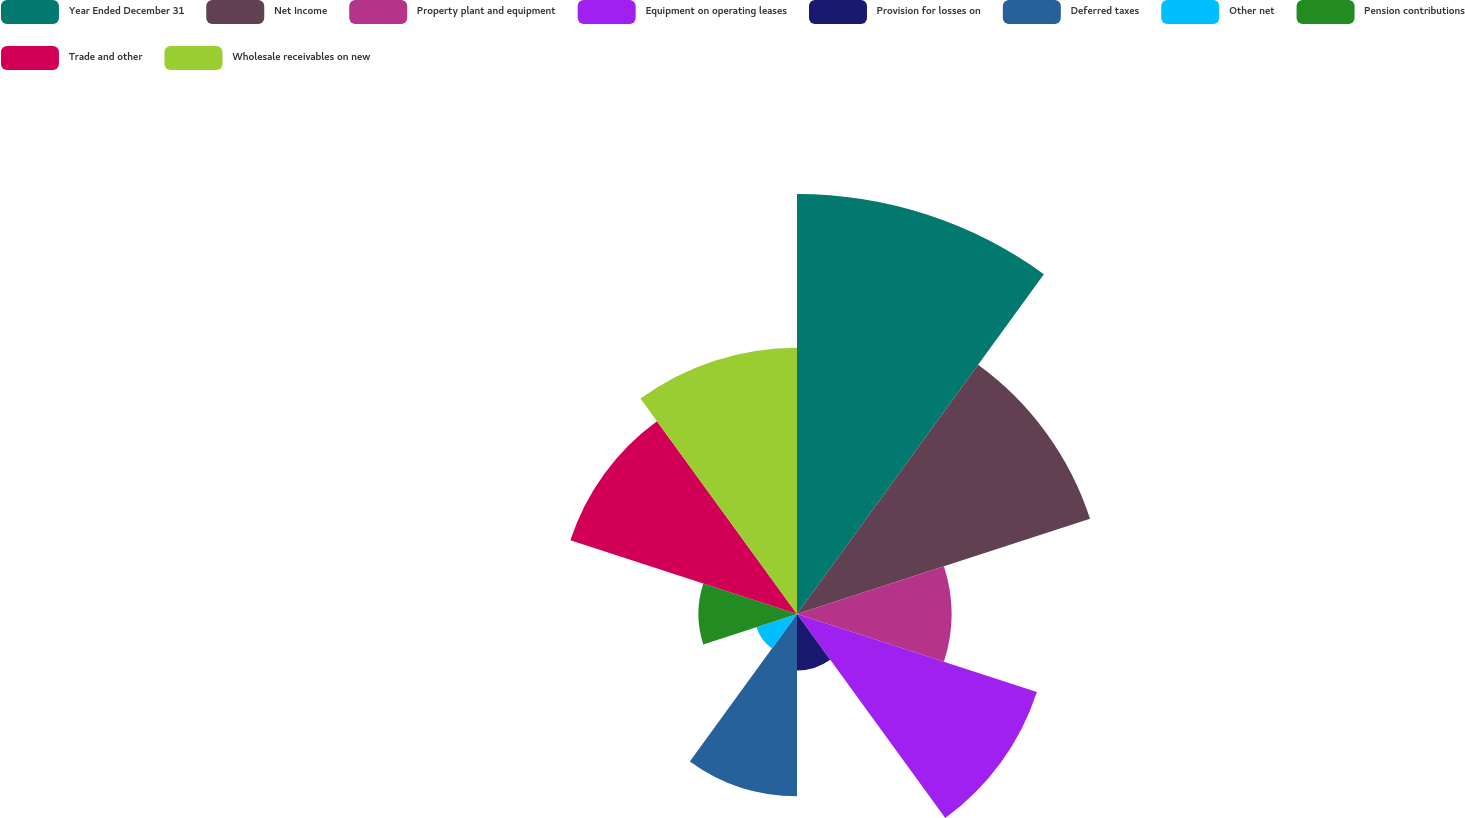Convert chart to OTSL. <chart><loc_0><loc_0><loc_500><loc_500><pie_chart><fcel>Year Ended December 31<fcel>Net Income<fcel>Property plant and equipment<fcel>Equipment on operating leases<fcel>Provision for losses on<fcel>Deferred taxes<fcel>Other net<fcel>Pension contributions<fcel>Trade and other<fcel>Wholesale receivables on new<nl><fcel>20.8%<fcel>15.26%<fcel>7.65%<fcel>12.49%<fcel>2.8%<fcel>9.03%<fcel>2.11%<fcel>4.88%<fcel>11.8%<fcel>13.19%<nl></chart> 